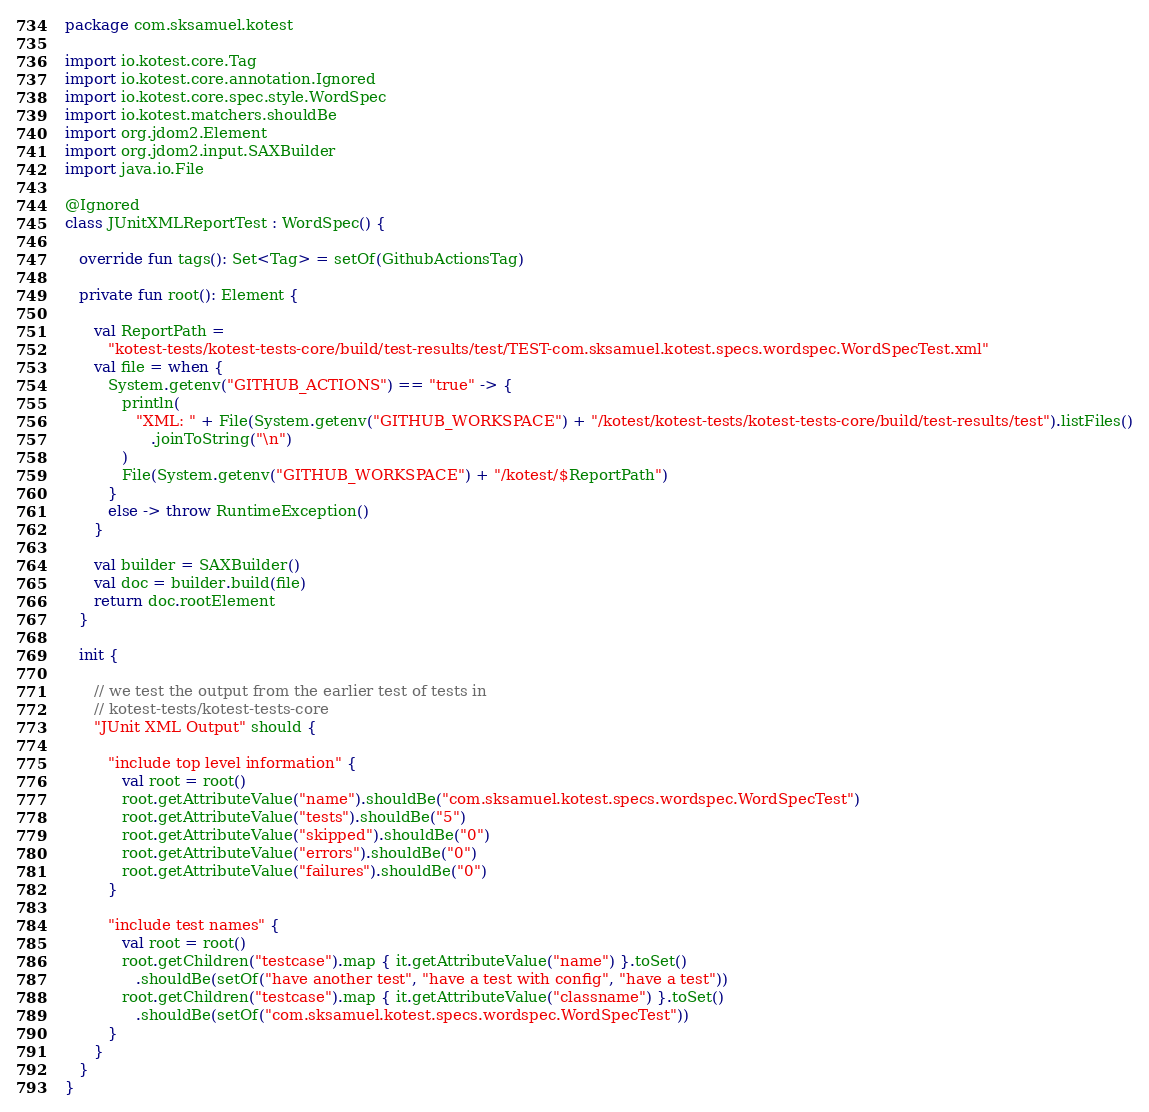<code> <loc_0><loc_0><loc_500><loc_500><_Kotlin_>package com.sksamuel.kotest

import io.kotest.core.Tag
import io.kotest.core.annotation.Ignored
import io.kotest.core.spec.style.WordSpec
import io.kotest.matchers.shouldBe
import org.jdom2.Element
import org.jdom2.input.SAXBuilder
import java.io.File

@Ignored
class JUnitXMLReportTest : WordSpec() {

   override fun tags(): Set<Tag> = setOf(GithubActionsTag)

   private fun root(): Element {

      val ReportPath =
         "kotest-tests/kotest-tests-core/build/test-results/test/TEST-com.sksamuel.kotest.specs.wordspec.WordSpecTest.xml"
      val file = when {
         System.getenv("GITHUB_ACTIONS") == "true" -> {
            println(
               "XML: " + File(System.getenv("GITHUB_WORKSPACE") + "/kotest/kotest-tests/kotest-tests-core/build/test-results/test").listFiles()
                  .joinToString("\n")
            )
            File(System.getenv("GITHUB_WORKSPACE") + "/kotest/$ReportPath")
         }
         else -> throw RuntimeException()
      }

      val builder = SAXBuilder()
      val doc = builder.build(file)
      return doc.rootElement
   }

   init {

      // we test the output from the earlier test of tests in
      // kotest-tests/kotest-tests-core
      "JUnit XML Output" should {

         "include top level information" {
            val root = root()
            root.getAttributeValue("name").shouldBe("com.sksamuel.kotest.specs.wordspec.WordSpecTest")
            root.getAttributeValue("tests").shouldBe("5")
            root.getAttributeValue("skipped").shouldBe("0")
            root.getAttributeValue("errors").shouldBe("0")
            root.getAttributeValue("failures").shouldBe("0")
         }

         "include test names" {
            val root = root()
            root.getChildren("testcase").map { it.getAttributeValue("name") }.toSet()
               .shouldBe(setOf("have another test", "have a test with config", "have a test"))
            root.getChildren("testcase").map { it.getAttributeValue("classname") }.toSet()
               .shouldBe(setOf("com.sksamuel.kotest.specs.wordspec.WordSpecTest"))
         }
      }
   }
}
</code> 